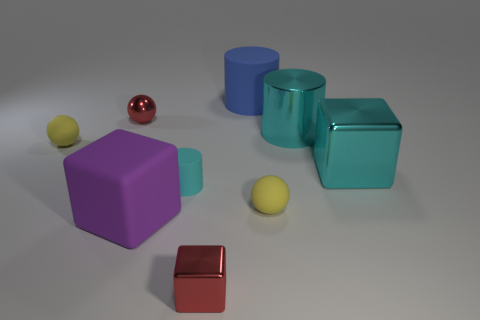What number of other things are the same color as the big rubber cylinder?
Make the answer very short. 0. The large object that is to the right of the large blue rubber thing and to the left of the cyan metallic block has what shape?
Your answer should be very brief. Cylinder. Are there any big metallic objects in front of the cylinder left of the rubber cylinder that is behind the big cyan metallic cylinder?
Offer a terse response. No. What number of other things are the same material as the blue object?
Give a very brief answer. 4. How many cylinders are there?
Your answer should be compact. 3. How many things are large yellow metal cylinders or cyan metal things behind the cyan metallic cube?
Your answer should be very brief. 1. There is a red metallic object right of the cyan rubber object; does it have the same size as the big matte cube?
Ensure brevity in your answer.  No. How many shiny objects are either big yellow spheres or cubes?
Your response must be concise. 2. What is the size of the cyan shiny thing on the right side of the shiny cylinder?
Provide a short and direct response. Large. Is the shape of the blue rubber thing the same as the small cyan rubber object?
Your answer should be very brief. Yes. 